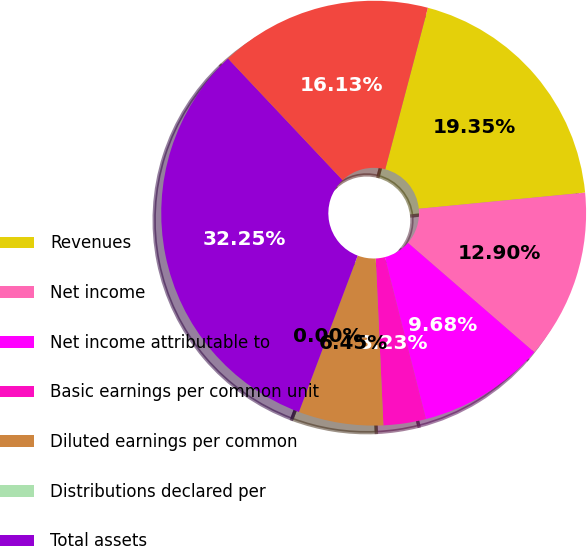<chart> <loc_0><loc_0><loc_500><loc_500><pie_chart><fcel>Revenues<fcel>Net income<fcel>Net income attributable to<fcel>Basic earnings per common unit<fcel>Diluted earnings per common<fcel>Distributions declared per<fcel>Total assets<fcel>Debt<nl><fcel>19.35%<fcel>12.9%<fcel>9.68%<fcel>3.23%<fcel>6.45%<fcel>0.0%<fcel>32.25%<fcel>16.13%<nl></chart> 